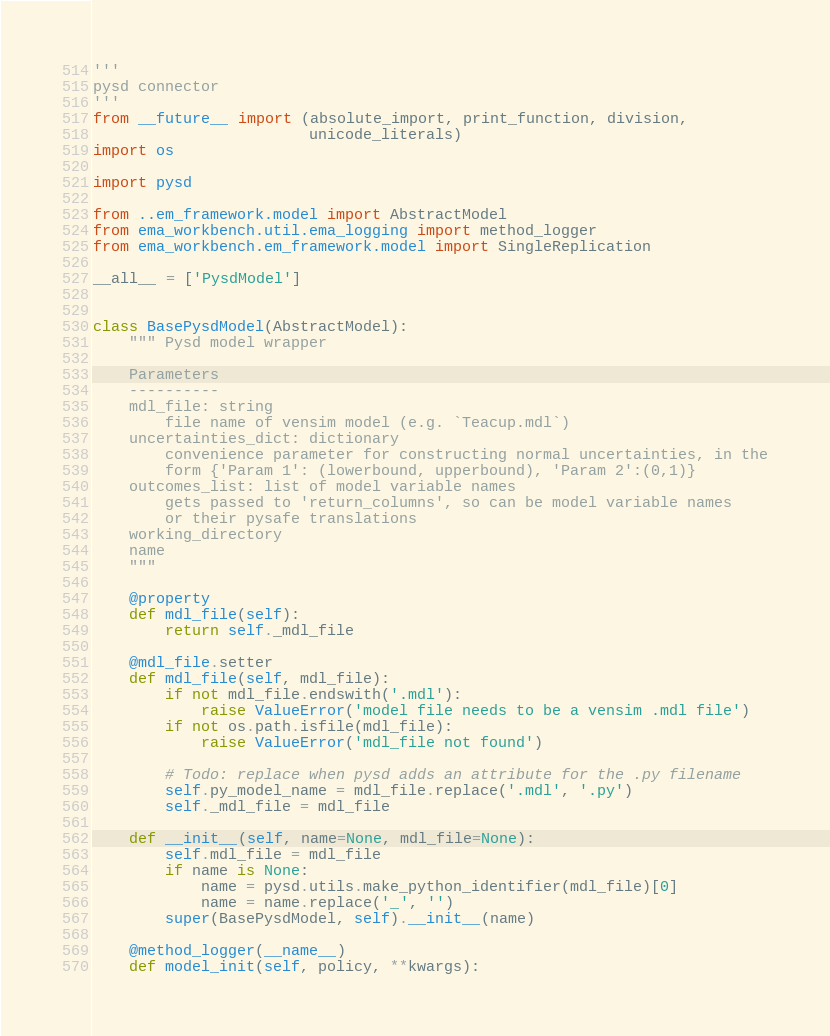Convert code to text. <code><loc_0><loc_0><loc_500><loc_500><_Python_>'''
pysd connector
'''
from __future__ import (absolute_import, print_function, division,
                        unicode_literals)
import os

import pysd

from ..em_framework.model import AbstractModel
from ema_workbench.util.ema_logging import method_logger
from ema_workbench.em_framework.model import SingleReplication

__all__ = ['PysdModel']


class BasePysdModel(AbstractModel):
    """ Pysd model wrapper

    Parameters
    ----------
    mdl_file: string
        file name of vensim model (e.g. `Teacup.mdl`)
    uncertainties_dict: dictionary
        convenience parameter for constructing normal uncertainties, in the
        form {'Param 1': (lowerbound, upperbound), 'Param 2':(0,1)}
    outcomes_list: list of model variable names
        gets passed to 'return_columns', so can be model variable names
        or their pysafe translations
    working_directory
    name
    """

    @property
    def mdl_file(self):
        return self._mdl_file

    @mdl_file.setter
    def mdl_file(self, mdl_file):
        if not mdl_file.endswith('.mdl'):
            raise ValueError('model file needs to be a vensim .mdl file')
        if not os.path.isfile(mdl_file):
            raise ValueError('mdl_file not found')

        # Todo: replace when pysd adds an attribute for the .py filename
        self.py_model_name = mdl_file.replace('.mdl', '.py')
        self._mdl_file = mdl_file

    def __init__(self, name=None, mdl_file=None):
        self.mdl_file = mdl_file
        if name is None:
            name = pysd.utils.make_python_identifier(mdl_file)[0]
            name = name.replace('_', '')
        super(BasePysdModel, self).__init__(name)

    @method_logger(__name__)
    def model_init(self, policy, **kwargs):</code> 